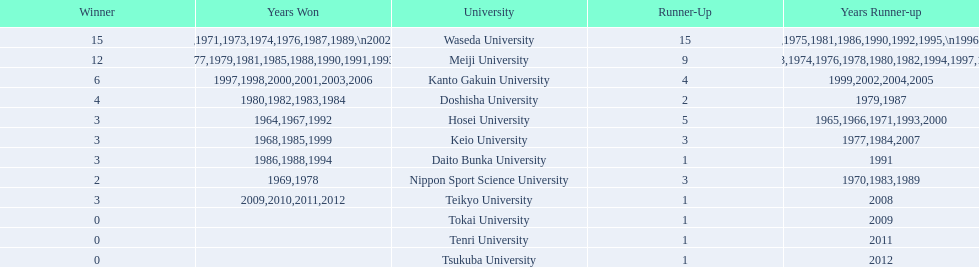Hosei won in 1964. who won the next year? Waseda University. 